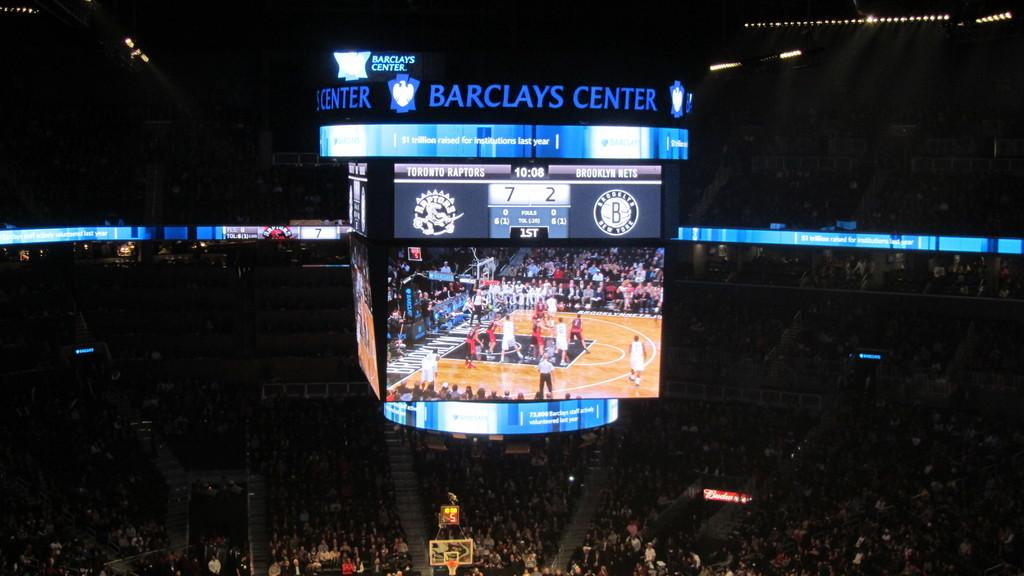How many people are in the image? There is a group of people in the image. Where are the people located? The people are in a stadium. What can be seen in the center of the image? There is a projector screen in the center of the image. How many people are in the crowd outside the stadium in the image? There is no crowd outside the stadium mentioned in the image; the people are already inside the stadium. 